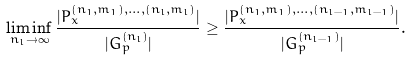Convert formula to latex. <formula><loc_0><loc_0><loc_500><loc_500>\liminf _ { n _ { l } \to \infty } \frac { | P _ { x } ^ { ( n _ { 1 } , m _ { 1 } ) , \dots , ( n _ { l } , m _ { l } ) } | } { | G _ { p } ^ { ( n _ { l } ) } | } \geq \frac { | P _ { x } ^ { ( n _ { 1 } , m _ { 1 } ) , \dots , ( n _ { l - 1 } , m _ { l - 1 } ) } | } { | G _ { p } ^ { ( n _ { l - 1 } ) } | } .</formula> 